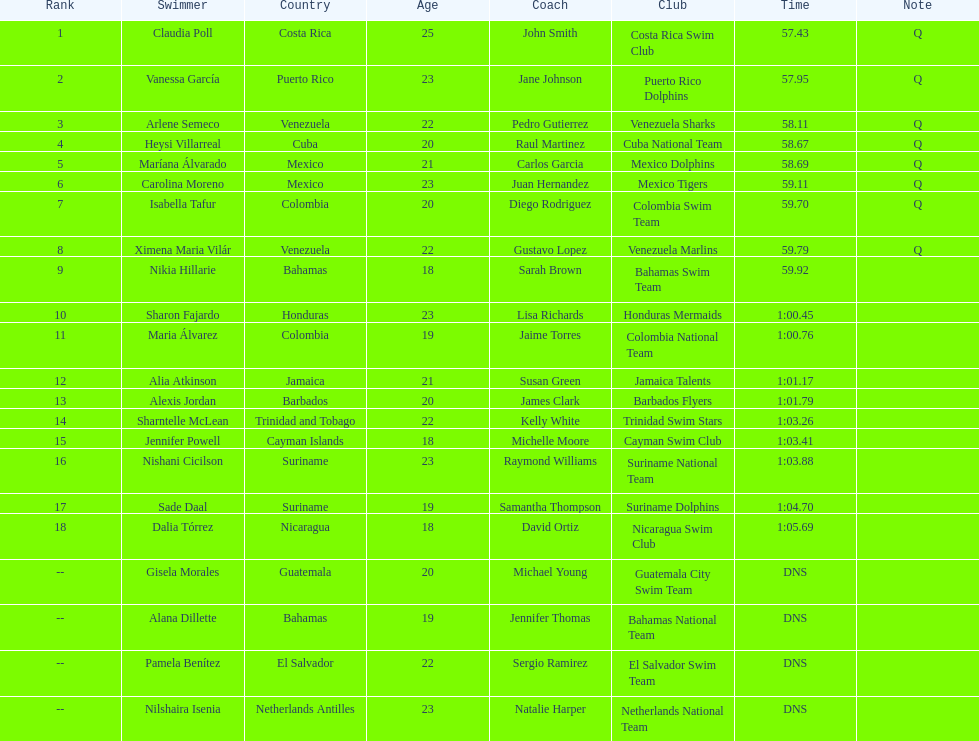Who finished after claudia poll? Vanessa García. 